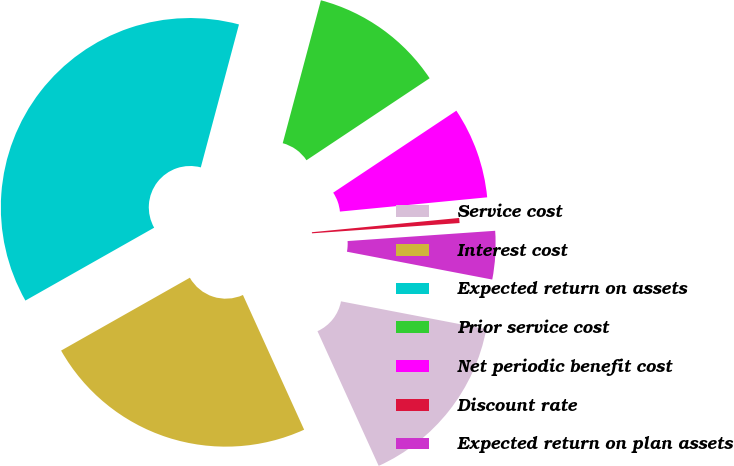Convert chart. <chart><loc_0><loc_0><loc_500><loc_500><pie_chart><fcel>Service cost<fcel>Interest cost<fcel>Expected return on assets<fcel>Prior service cost<fcel>Net periodic benefit cost<fcel>Discount rate<fcel>Expected return on plan assets<nl><fcel>15.2%<fcel>23.59%<fcel>37.35%<fcel>11.5%<fcel>7.81%<fcel>0.43%<fcel>4.12%<nl></chart> 